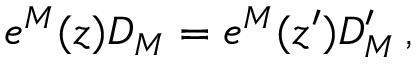<formula> <loc_0><loc_0><loc_500><loc_500>e ^ { M } ( z ) D _ { M } = e ^ { M } ( z ^ { \prime } ) D _ { M } ^ { \prime } \, ,</formula> 